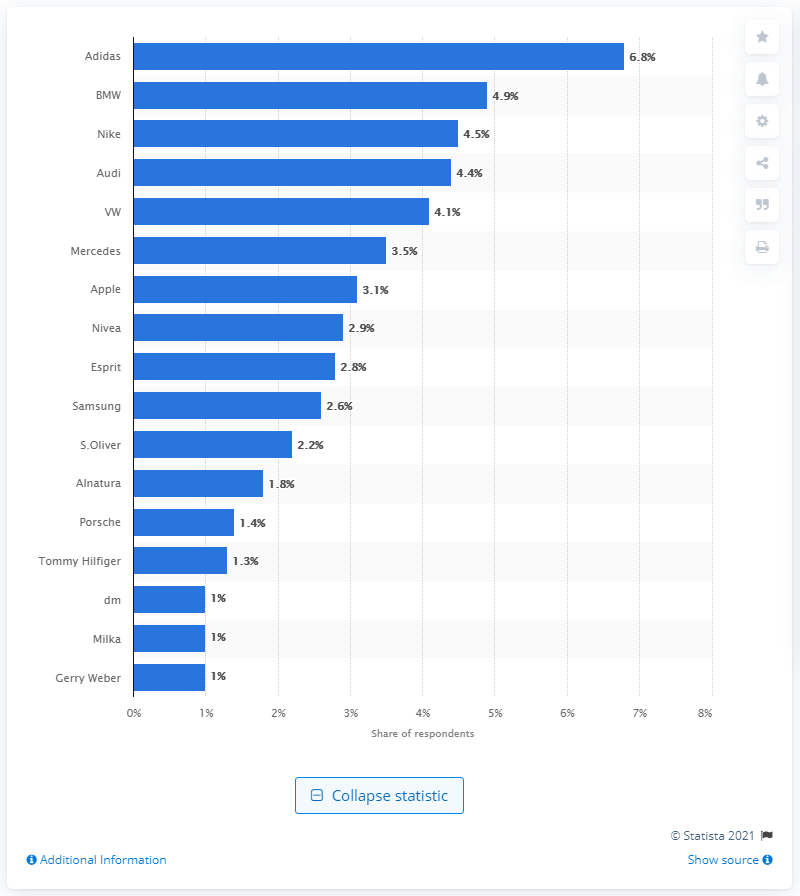Point out several critical features in this image. In 2014, BMW was the most popular brand in Germany. 